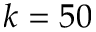<formula> <loc_0><loc_0><loc_500><loc_500>k = 5 0</formula> 